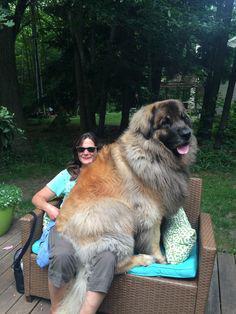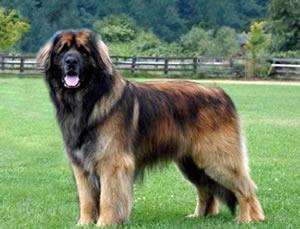The first image is the image on the left, the second image is the image on the right. Examine the images to the left and right. Is the description "In one image, a woman in glasses is on the left of a dog that is sitting up, and the other image includes a dog standing in profile on grass." accurate? Answer yes or no. Yes. The first image is the image on the left, the second image is the image on the right. Given the left and right images, does the statement "There is a large body of water in the background of at least one of the pictures." hold true? Answer yes or no. No. 